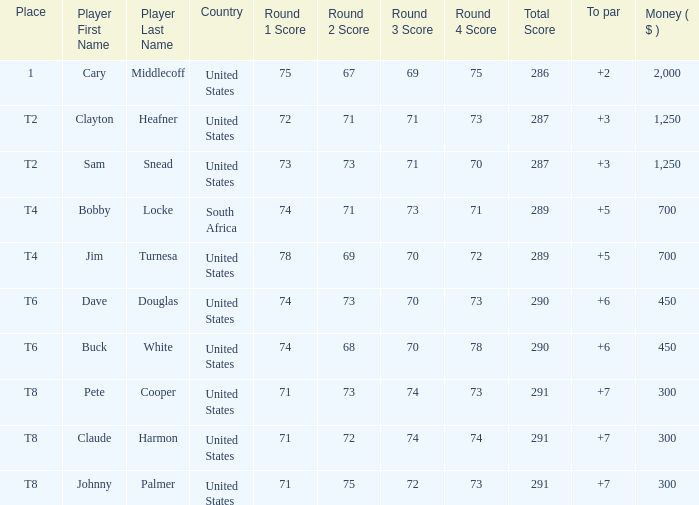What is the Johnny Palmer with a To larger than 6 Money sum? 300.0. 